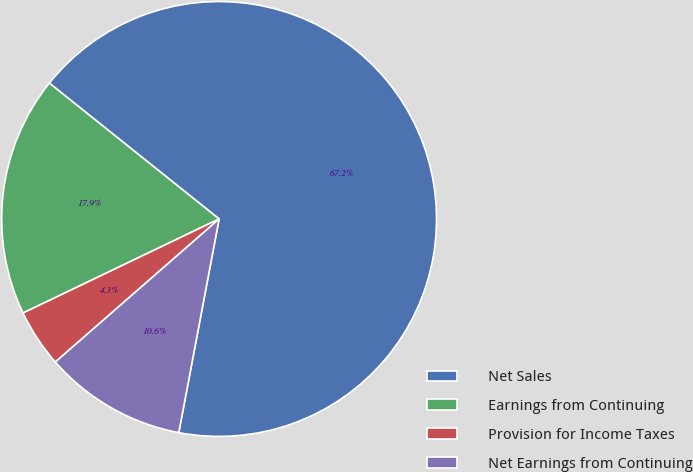Convert chart to OTSL. <chart><loc_0><loc_0><loc_500><loc_500><pie_chart><fcel>Net Sales<fcel>Earnings from Continuing<fcel>Provision for Income Taxes<fcel>Net Earnings from Continuing<nl><fcel>67.23%<fcel>17.86%<fcel>4.31%<fcel>10.6%<nl></chart> 